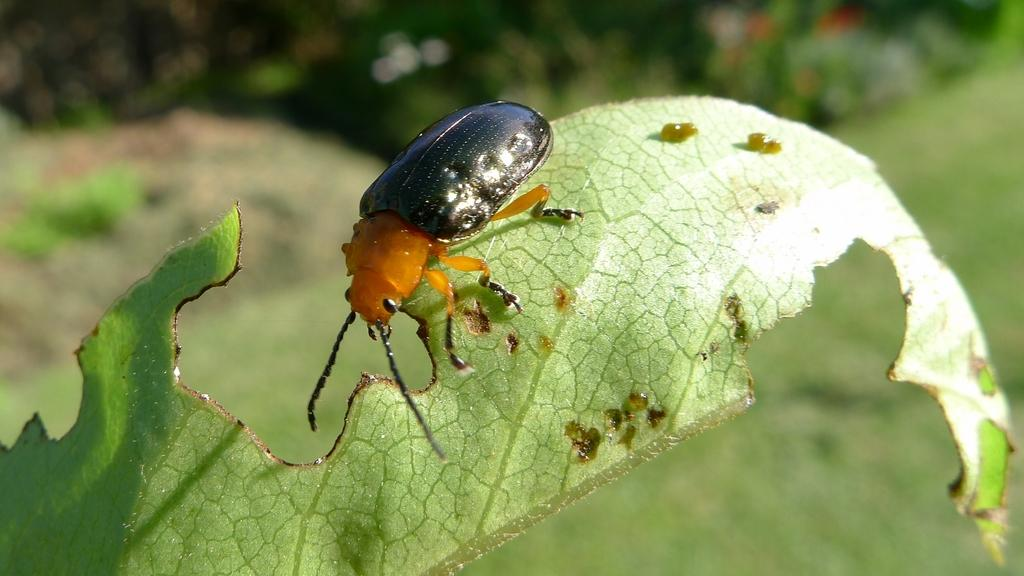What is present in the image? There is an insect in the image. Can you describe the insect's appearance? The insect has black and brown coloring. Where is the insect located in the image? The insect is on a leaf. How would you describe the background of the image? The background of the image is blurred. What type of degree is the insect holding in the image? There is no degree present in the image, as insects do not hold degrees. 